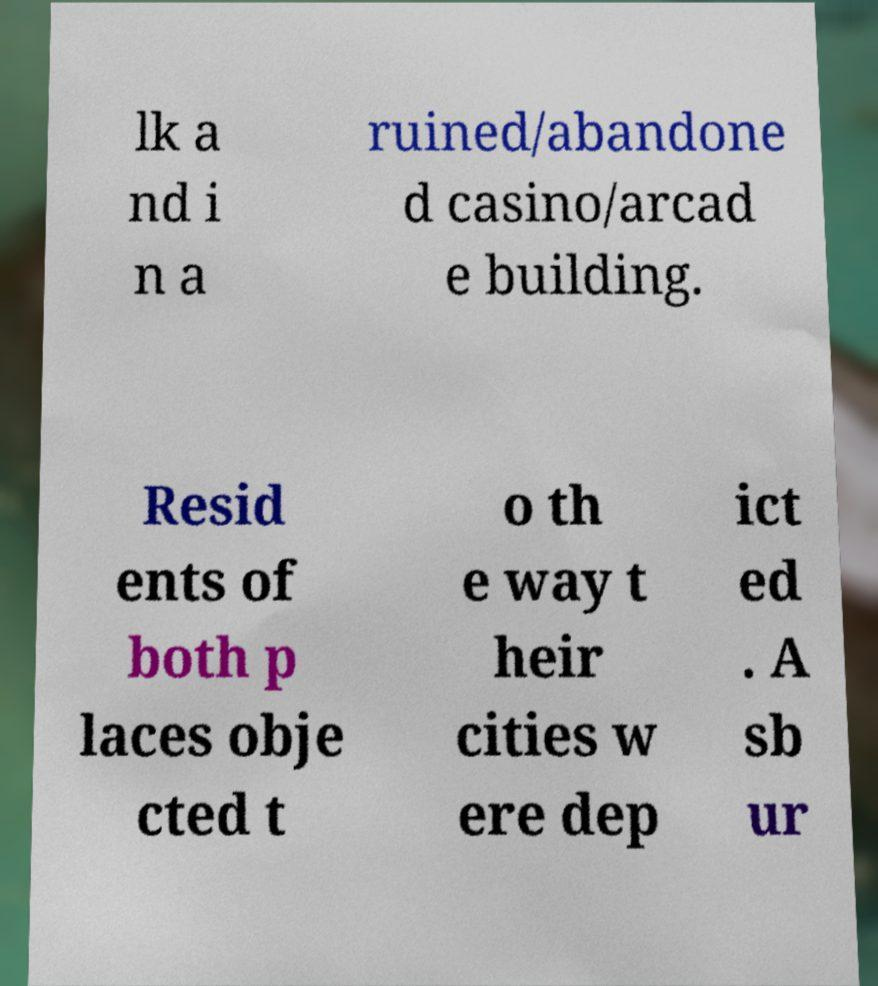Could you extract and type out the text from this image? lk a nd i n a ruined/abandone d casino/arcad e building. Resid ents of both p laces obje cted t o th e way t heir cities w ere dep ict ed . A sb ur 